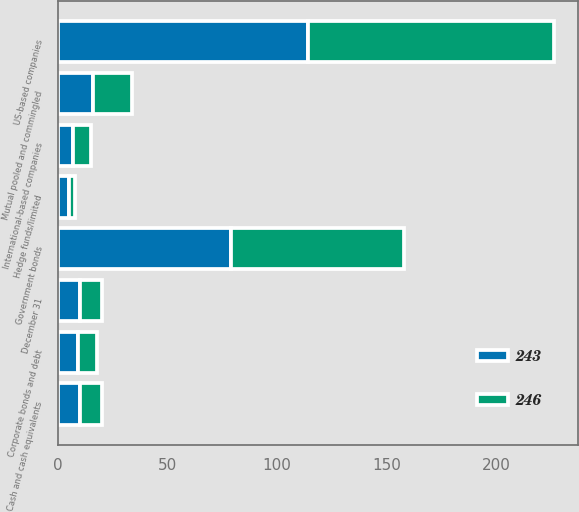<chart> <loc_0><loc_0><loc_500><loc_500><stacked_bar_chart><ecel><fcel>December 31<fcel>Cash and cash equivalents<fcel>US-based companies<fcel>International-based companies<fcel>Government bonds<fcel>Corporate bonds and debt<fcel>Mutual pooled and commingled<fcel>Hedge funds/limited<nl><fcel>243<fcel>10<fcel>10<fcel>114<fcel>7<fcel>79<fcel>9<fcel>16<fcel>5<nl><fcel>246<fcel>10<fcel>10<fcel>112<fcel>8<fcel>79<fcel>9<fcel>18<fcel>3<nl></chart> 